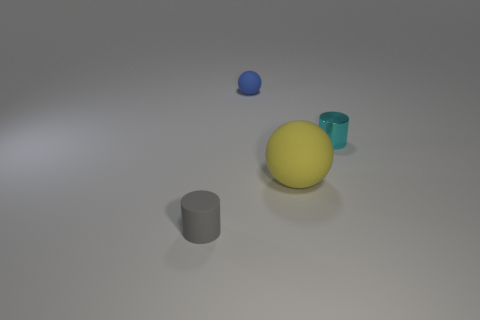Add 2 yellow metal things. How many objects exist? 6 Subtract all small shiny objects. Subtract all large things. How many objects are left? 2 Add 3 gray cylinders. How many gray cylinders are left? 4 Add 4 gray matte objects. How many gray matte objects exist? 5 Subtract 0 blue blocks. How many objects are left? 4 